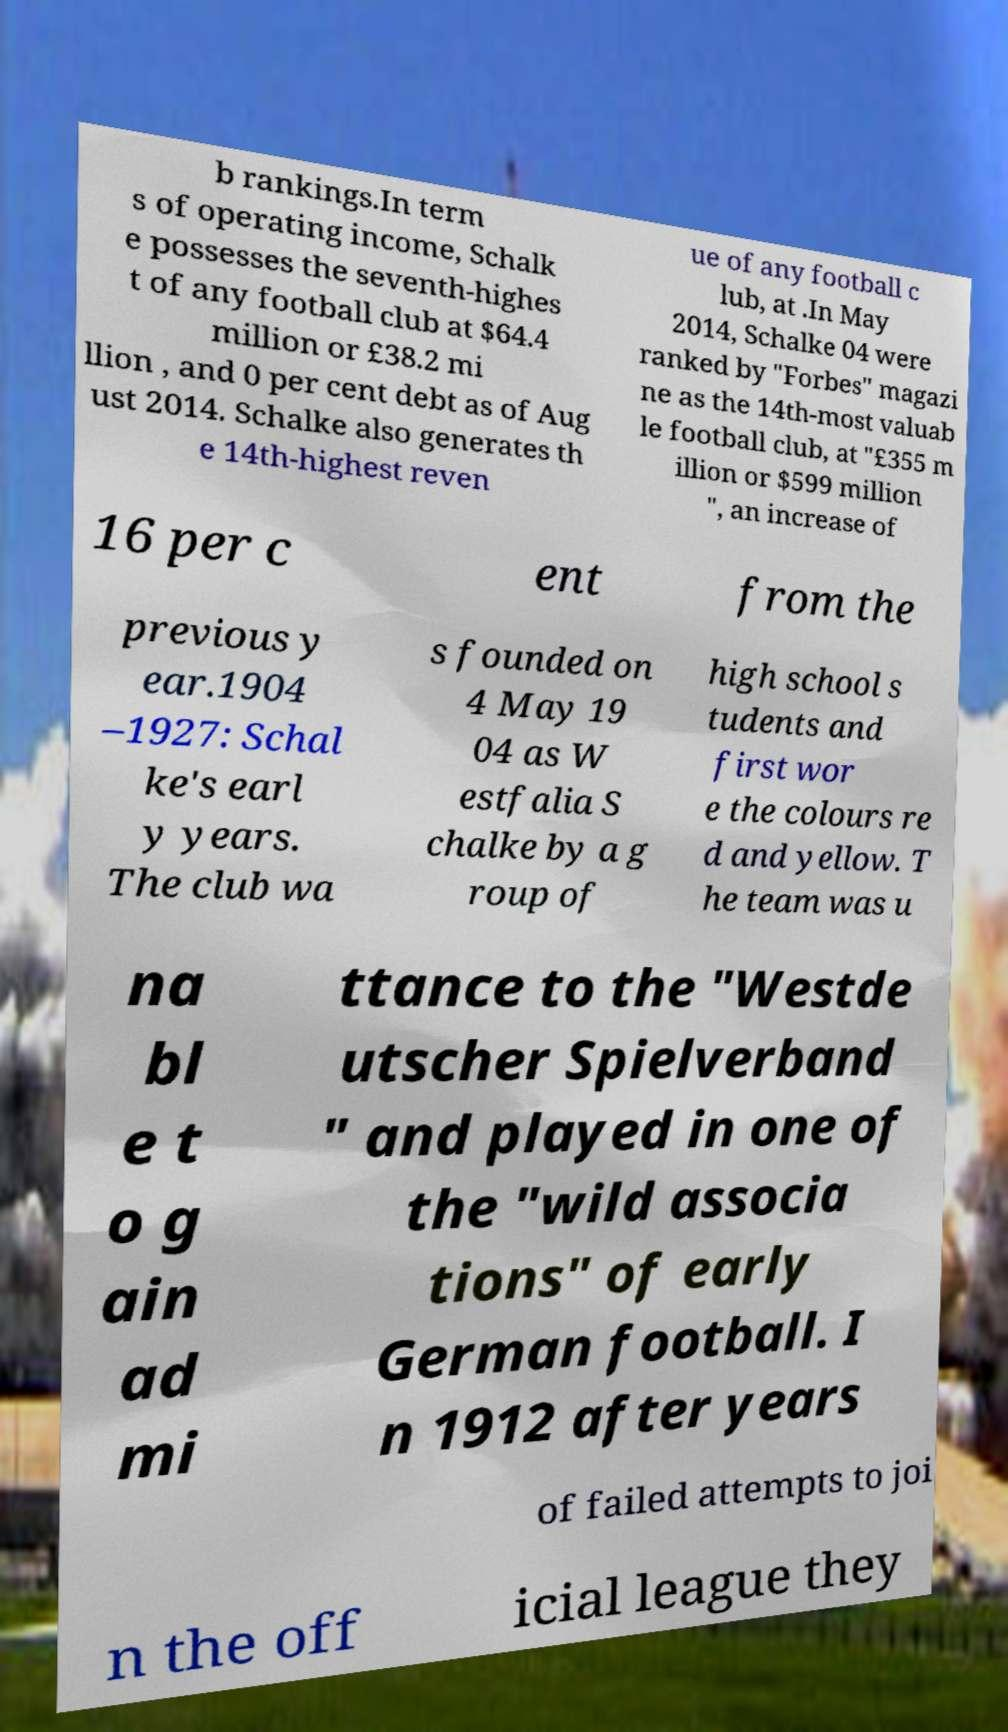What messages or text are displayed in this image? I need them in a readable, typed format. b rankings.In term s of operating income, Schalk e possesses the seventh-highes t of any football club at $64.4 million or £38.2 mi llion , and 0 per cent debt as of Aug ust 2014. Schalke also generates th e 14th-highest reven ue of any football c lub, at .In May 2014, Schalke 04 were ranked by "Forbes" magazi ne as the 14th-most valuab le football club, at "£355 m illion or $599 million ", an increase of 16 per c ent from the previous y ear.1904 –1927: Schal ke's earl y years. The club wa s founded on 4 May 19 04 as W estfalia S chalke by a g roup of high school s tudents and first wor e the colours re d and yellow. T he team was u na bl e t o g ain ad mi ttance to the "Westde utscher Spielverband " and played in one of the "wild associa tions" of early German football. I n 1912 after years of failed attempts to joi n the off icial league they 